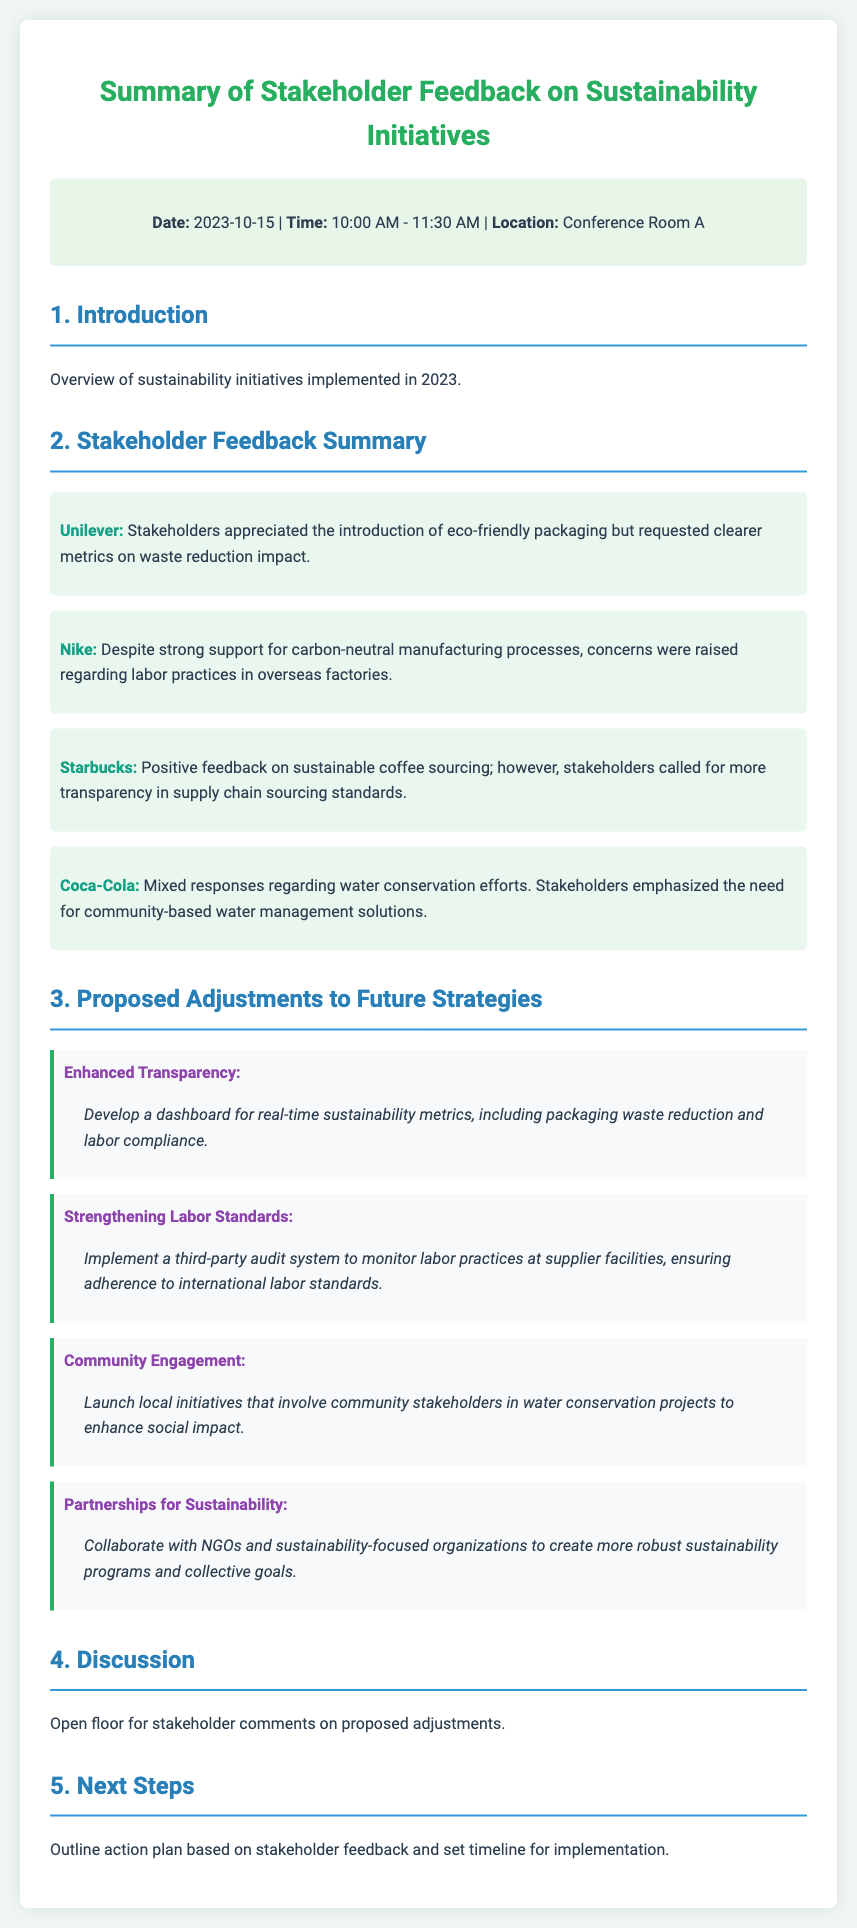What is the date of the stakeholder feedback meeting? The date is mentioned in the meta-info section of the document.
Answer: 2023-10-15 What company provided feedback about eco-friendly packaging? The feedback is specified in the feedback summary section, highlighting the feedback from Unilever regarding eco-friendly packaging.
Answer: Unilever What was emphasized by stakeholders regarding Coca-Cola's water conservation efforts? The document indicates that stakeholders emphasized the need for community-based water management solutions for Coca-Cola.
Answer: Community-based water management solutions What is one of the proposed adjustments related to labor standards? The proposed adjustments section outlines an initiative focused on enhancing labor practices, specifically mentioning a third-party audit system.
Answer: Third-party audit system Which company received positive feedback for sustainable coffee sourcing? The feedback summary indicates that Starbucks received positive feedback regarding sustainable coffee sourcing.
Answer: Starbucks How long did the stakeholder feedback meeting last? The duration of the meeting can be calculated from the start and end times provided in the meta-info section.
Answer: 1 hour 30 minutes What is one of the initiatives focused on transparency? The proposed adjustments section describes an initiative aimed at improving transparency through a dashboard for sustainability metrics.
Answer: Enhanced Transparency What action is suggested for strengthening labor standards? The document mentions implementing a system to monitor labor practices as part of strengthening labor standards.
Answer: Third-party audit system What is the focus of the proposed "Community Engagement" initiative? The section on proposed adjustments details that this initiative aims to involve community stakeholders in water conservation projects.
Answer: Involve community stakeholders in water conservation projects 